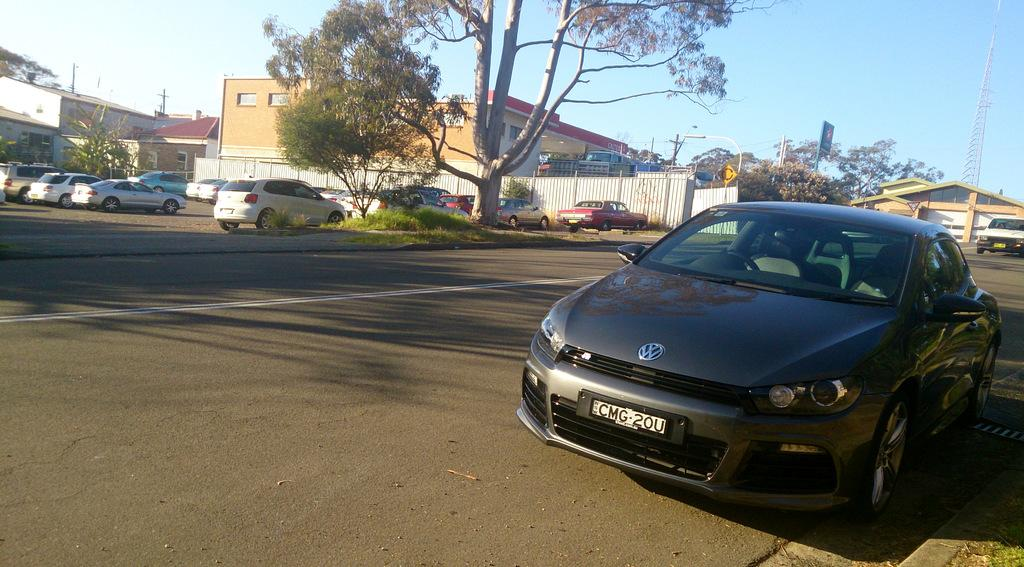What types of objects can be seen in the image? There are vehicles, a road, ground with grass, trees, plants, poles, towers, posters, buildings, and sign boards visible in the image. Can you describe the buildings in the image? The buildings have windows and are part of the urban landscape. What is visible in the sky in the image? The sky is visible in the image. Where can the quill be found in the image? There is no quill present in the image. What type of clothing is hanging on the shelf in the image? There is no shelf or clothing visible in the image. 